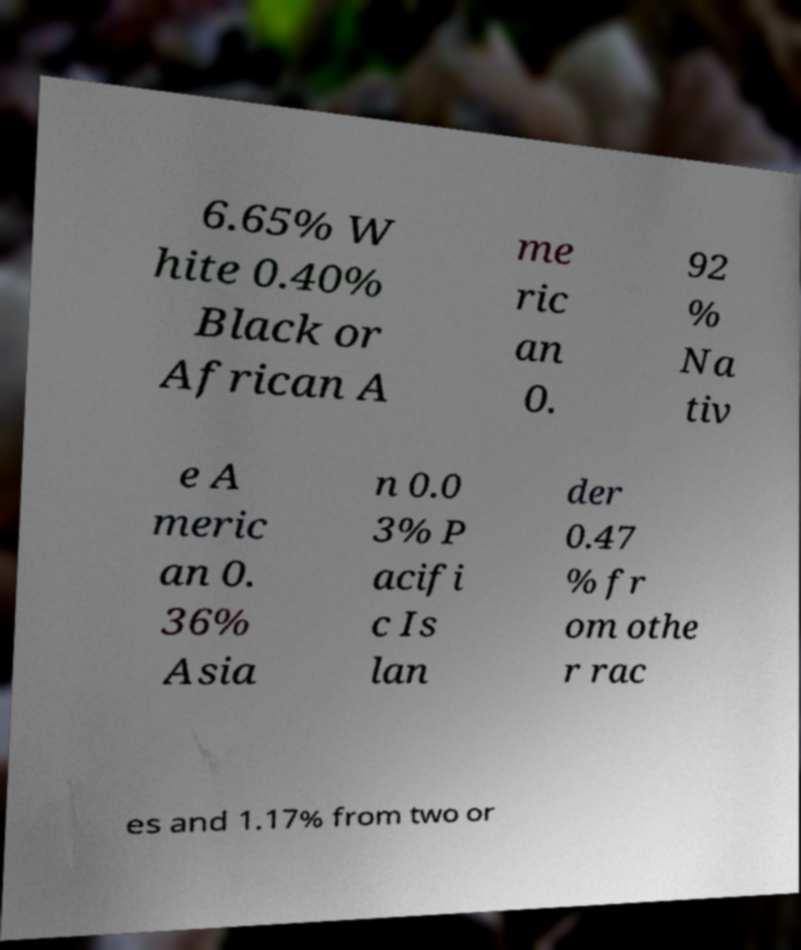There's text embedded in this image that I need extracted. Can you transcribe it verbatim? 6.65% W hite 0.40% Black or African A me ric an 0. 92 % Na tiv e A meric an 0. 36% Asia n 0.0 3% P acifi c Is lan der 0.47 % fr om othe r rac es and 1.17% from two or 